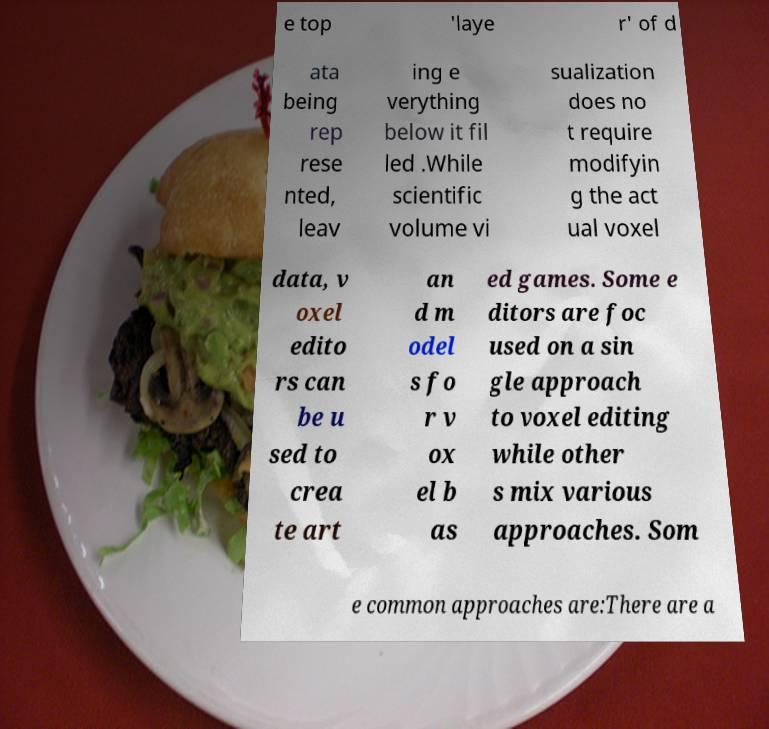Please identify and transcribe the text found in this image. e top 'laye r' of d ata being rep rese nted, leav ing e verything below it fil led .While scientific volume vi sualization does no t require modifyin g the act ual voxel data, v oxel edito rs can be u sed to crea te art an d m odel s fo r v ox el b as ed games. Some e ditors are foc used on a sin gle approach to voxel editing while other s mix various approaches. Som e common approaches are:There are a 